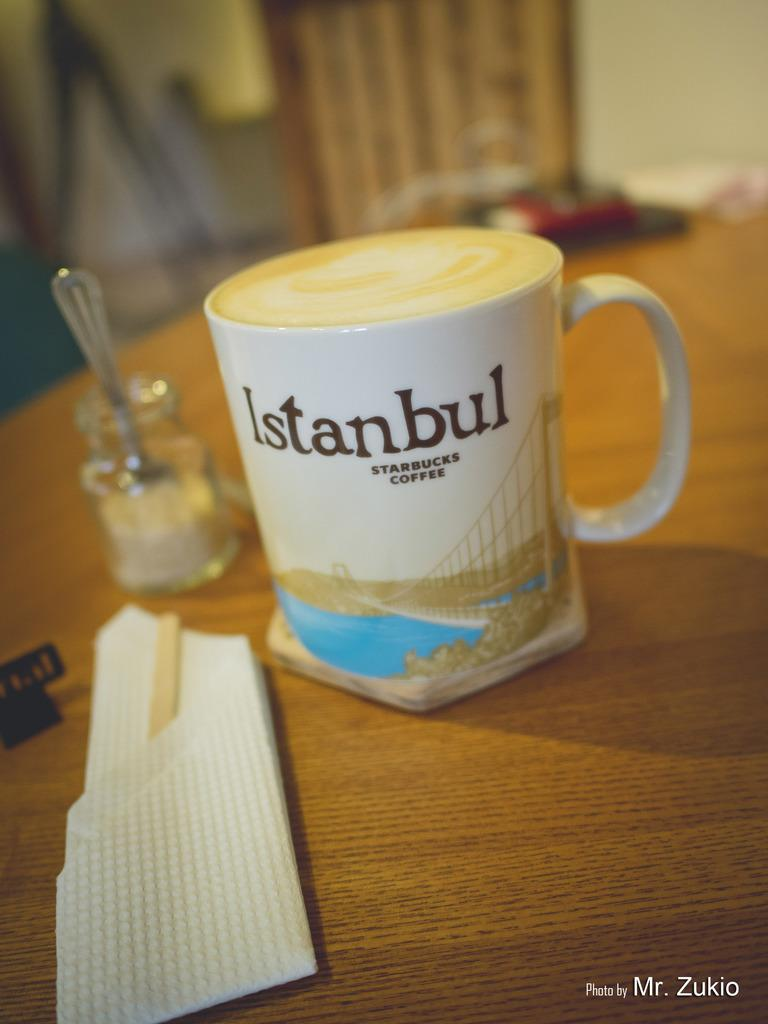<image>
Present a compact description of the photo's key features. A Starbucks Coffee cup with a scene from Istanbul on it sits on a wooden table. 